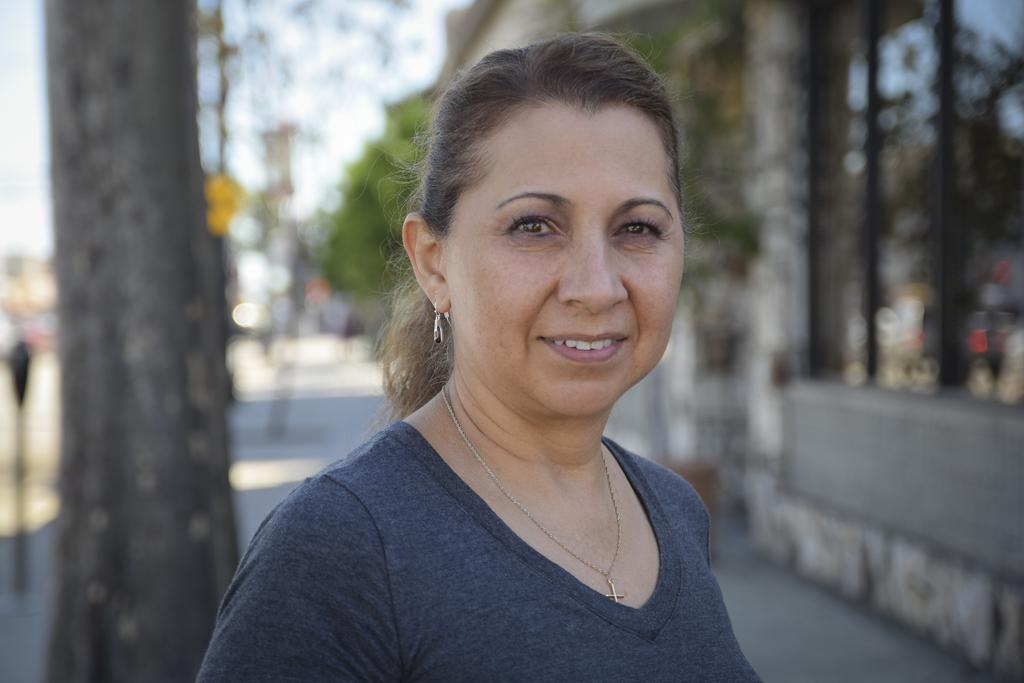Who is the main subject in the image? There is a lady in the image. What is the lady wearing? The lady is wearing a t-shirt. What can be seen in the background of the image? There are trees in the background of the image. How would you describe the background of the image? The background is blurry. What is the lady's temper like in the image? There is no information about the lady's temper in the image. Is there a hospital visible in the image? There is no hospital present in the image. 